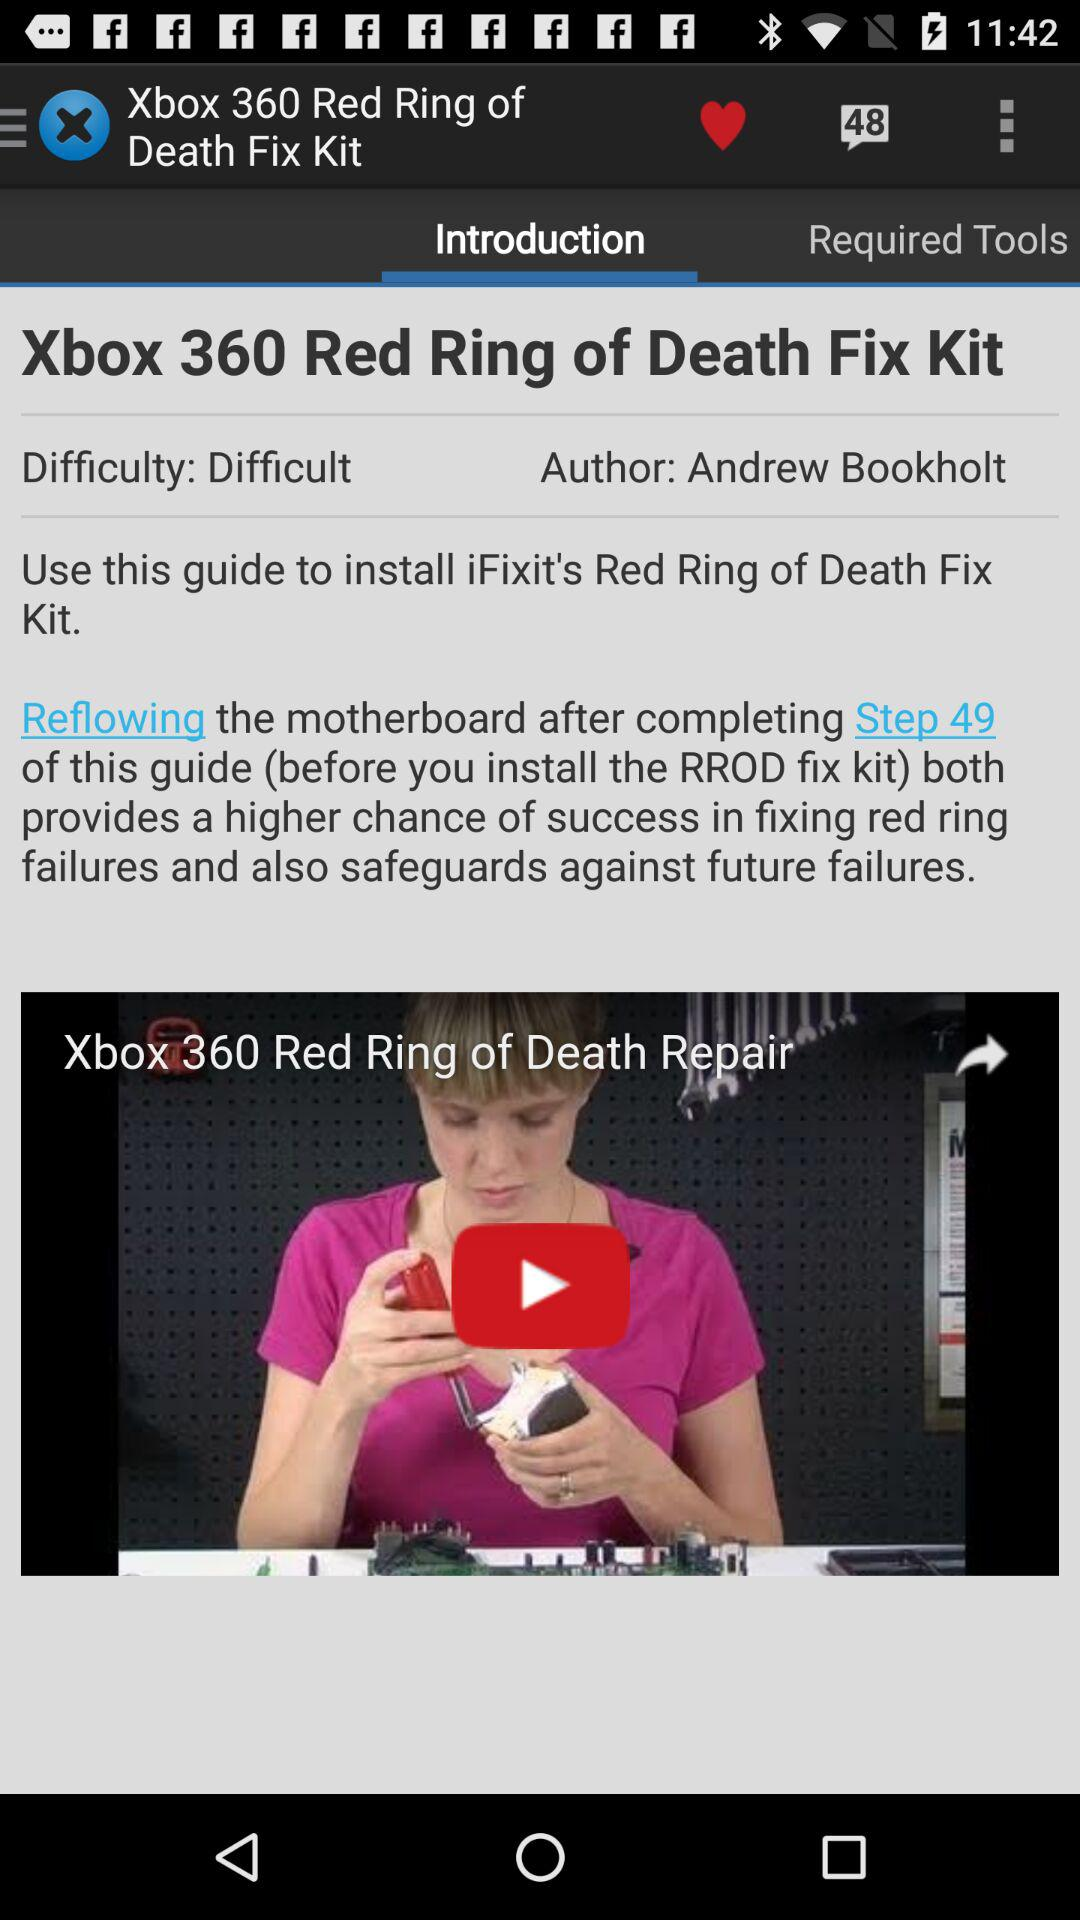What is the title of the video? The title of the video is "Xbox 360 Red Ring of Death Repair". 